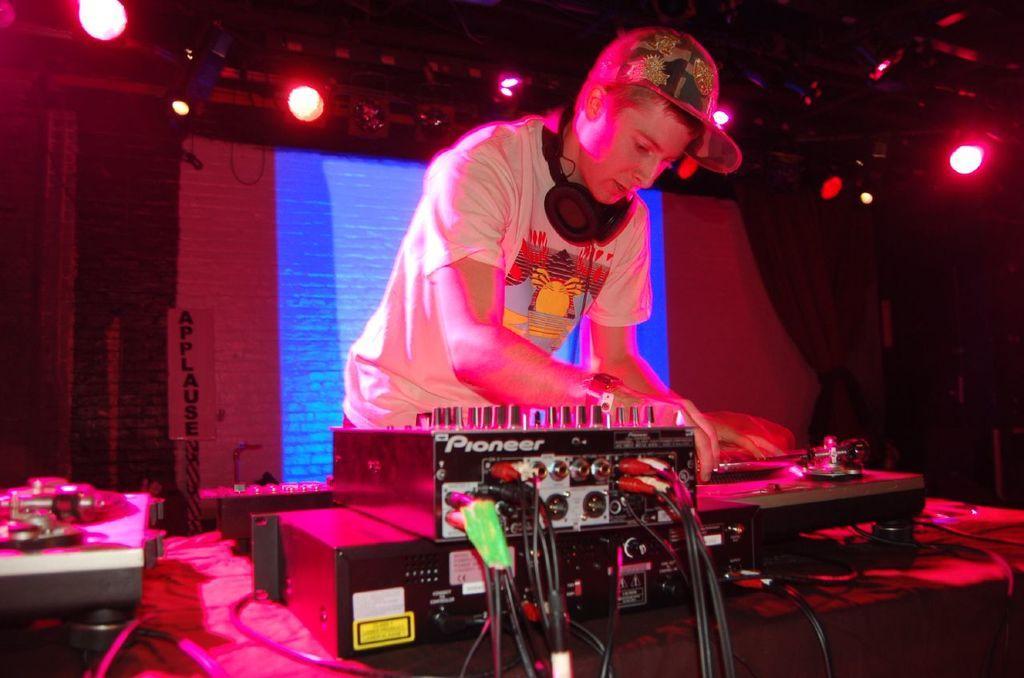How would you summarize this image in a sentence or two? In this picture we can see a man wore a cap and standing, headset, devices, lights, curtains, screen and in the background it is dark. 